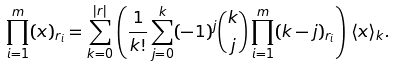Convert formula to latex. <formula><loc_0><loc_0><loc_500><loc_500>\prod _ { i = 1 } ^ { m } ( x ) _ { r _ { i } } = \sum _ { k = 0 } ^ { | { r } | } \left ( \frac { 1 } { k ! } \sum _ { j = 0 } ^ { k } ( - 1 ) ^ { j } \binom { k } { j } \prod _ { i = 1 } ^ { m } ( k - j ) _ { r _ { i } } \right ) \, \langle x \rangle _ { k } .</formula> 